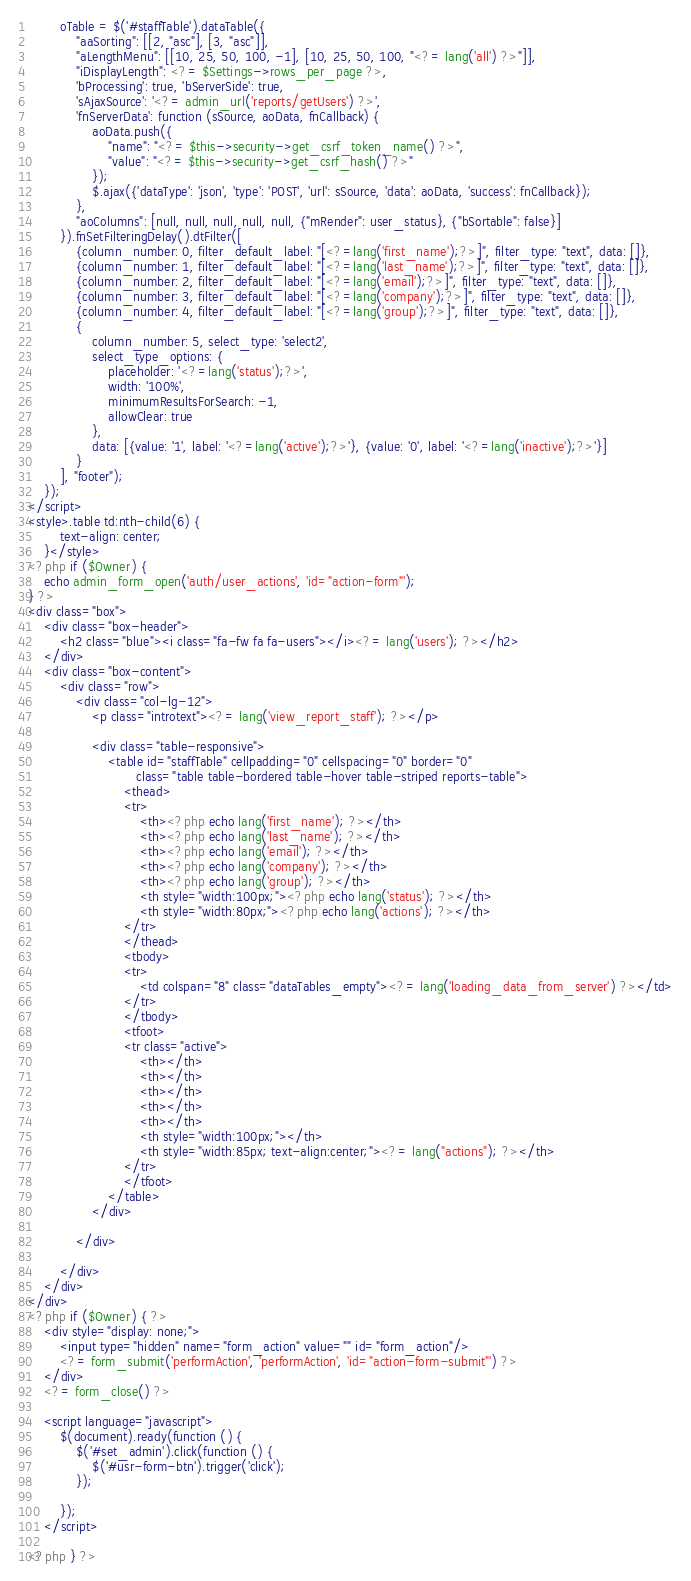<code> <loc_0><loc_0><loc_500><loc_500><_PHP_>        oTable = $('#staffTable').dataTable({
            "aaSorting": [[2, "asc"], [3, "asc"]],
            "aLengthMenu": [[10, 25, 50, 100, -1], [10, 25, 50, 100, "<?= lang('all') ?>"]],
            "iDisplayLength": <?= $Settings->rows_per_page ?>,
            'bProcessing': true, 'bServerSide': true,
            'sAjaxSource': '<?= admin_url('reports/getUsers') ?>',
            'fnServerData': function (sSource, aoData, fnCallback) {
                aoData.push({
                    "name": "<?= $this->security->get_csrf_token_name() ?>",
                    "value": "<?= $this->security->get_csrf_hash() ?>"
                });
                $.ajax({'dataType': 'json', 'type': 'POST', 'url': sSource, 'data': aoData, 'success': fnCallback});
            },
            "aoColumns": [null, null, null, null, null, {"mRender": user_status}, {"bSortable": false}]
        }).fnSetFilteringDelay().dtFilter([
            {column_number: 0, filter_default_label: "[<?=lang('first_name');?>]", filter_type: "text", data: []},
            {column_number: 1, filter_default_label: "[<?=lang('last_name');?>]", filter_type: "text", data: []},
            {column_number: 2, filter_default_label: "[<?=lang('email');?>]", filter_type: "text", data: []},
            {column_number: 3, filter_default_label: "[<?=lang('company');?>]", filter_type: "text", data: []},
            {column_number: 4, filter_default_label: "[<?=lang('group');?>]", filter_type: "text", data: []},
            {
                column_number: 5, select_type: 'select2',
                select_type_options: {
                    placeholder: '<?=lang('status');?>',
                    width: '100%',
                    minimumResultsForSearch: -1,
                    allowClear: true
                },
                data: [{value: '1', label: '<?=lang('active');?>'}, {value: '0', label: '<?=lang('inactive');?>'}]
            }
        ], "footer");
    });
</script>
<style>.table td:nth-child(6) {
        text-align: center;
    }</style>
<?php if ($Owner) {
    echo admin_form_open('auth/user_actions', 'id="action-form"');
} ?>
<div class="box">
    <div class="box-header">
        <h2 class="blue"><i class="fa-fw fa fa-users"></i><?= lang('users'); ?></h2>
    </div>
    <div class="box-content">
        <div class="row">
            <div class="col-lg-12">
                <p class="introtext"><?= lang('view_report_staff'); ?></p>

                <div class="table-responsive">
                    <table id="staffTable" cellpadding="0" cellspacing="0" border="0"
                           class="table table-bordered table-hover table-striped reports-table">
                        <thead>
                        <tr>
                            <th><?php echo lang('first_name'); ?></th>
                            <th><?php echo lang('last_name'); ?></th>
                            <th><?php echo lang('email'); ?></th>
                            <th><?php echo lang('company'); ?></th>
                            <th><?php echo lang('group'); ?></th>
                            <th style="width:100px;"><?php echo lang('status'); ?></th>
                            <th style="width:80px;"><?php echo lang('actions'); ?></th>
                        </tr>
                        </thead>
                        <tbody>
                        <tr>
                            <td colspan="8" class="dataTables_empty"><?= lang('loading_data_from_server') ?></td>
                        </tr>
                        </tbody>
                        <tfoot>
                        <tr class="active">
                            <th></th>
                            <th></th>
                            <th></th>
                            <th></th>
                            <th></th>
                            <th style="width:100px;"></th>
                            <th style="width:85px; text-align:center;"><?= lang("actions"); ?></th>
                        </tr>
                        </tfoot>
                    </table>
                </div>

            </div>

        </div>
    </div>
</div>
<?php if ($Owner) { ?>
    <div style="display: none;">
        <input type="hidden" name="form_action" value="" id="form_action"/>
        <?= form_submit('performAction', 'performAction', 'id="action-form-submit"') ?>
    </div>
    <?= form_close() ?>

    <script language="javascript">
        $(document).ready(function () {
            $('#set_admin').click(function () {
                $('#usr-form-btn').trigger('click');
            });

        });
    </script>

<?php } ?></code> 